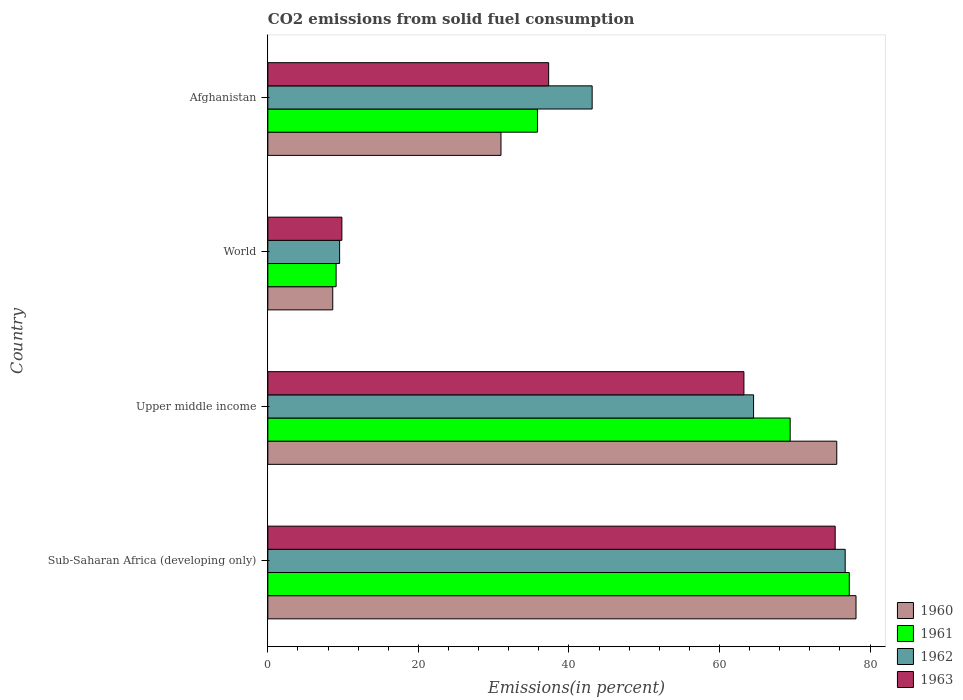How many different coloured bars are there?
Provide a short and direct response. 4. How many groups of bars are there?
Make the answer very short. 4. Are the number of bars on each tick of the Y-axis equal?
Make the answer very short. Yes. What is the label of the 3rd group of bars from the top?
Provide a succinct answer. Upper middle income. In how many cases, is the number of bars for a given country not equal to the number of legend labels?
Your answer should be compact. 0. What is the total CO2 emitted in 1963 in Upper middle income?
Make the answer very short. 63.25. Across all countries, what is the maximum total CO2 emitted in 1963?
Ensure brevity in your answer.  75.37. Across all countries, what is the minimum total CO2 emitted in 1962?
Offer a very short reply. 9.53. In which country was the total CO2 emitted in 1963 maximum?
Make the answer very short. Sub-Saharan Africa (developing only). In which country was the total CO2 emitted in 1960 minimum?
Give a very brief answer. World. What is the total total CO2 emitted in 1960 in the graph?
Offer a terse response. 193.32. What is the difference between the total CO2 emitted in 1962 in Upper middle income and that in World?
Your answer should be very brief. 55. What is the difference between the total CO2 emitted in 1960 in Sub-Saharan Africa (developing only) and the total CO2 emitted in 1963 in Afghanistan?
Offer a very short reply. 40.83. What is the average total CO2 emitted in 1961 per country?
Offer a very short reply. 47.88. What is the difference between the total CO2 emitted in 1961 and total CO2 emitted in 1962 in Afghanistan?
Make the answer very short. -7.26. In how many countries, is the total CO2 emitted in 1960 greater than 52 %?
Offer a terse response. 2. What is the ratio of the total CO2 emitted in 1960 in Sub-Saharan Africa (developing only) to that in Upper middle income?
Keep it short and to the point. 1.03. What is the difference between the highest and the second highest total CO2 emitted in 1963?
Keep it short and to the point. 12.13. What is the difference between the highest and the lowest total CO2 emitted in 1961?
Provide a short and direct response. 68.17. In how many countries, is the total CO2 emitted in 1961 greater than the average total CO2 emitted in 1961 taken over all countries?
Keep it short and to the point. 2. Is the sum of the total CO2 emitted in 1961 in Sub-Saharan Africa (developing only) and Upper middle income greater than the maximum total CO2 emitted in 1960 across all countries?
Offer a terse response. Yes. What does the 1st bar from the top in Upper middle income represents?
Provide a succinct answer. 1963. What does the 4th bar from the bottom in Sub-Saharan Africa (developing only) represents?
Ensure brevity in your answer.  1963. Is it the case that in every country, the sum of the total CO2 emitted in 1960 and total CO2 emitted in 1963 is greater than the total CO2 emitted in 1961?
Your response must be concise. Yes. How many countries are there in the graph?
Your answer should be compact. 4. Does the graph contain grids?
Provide a short and direct response. No. How many legend labels are there?
Give a very brief answer. 4. How are the legend labels stacked?
Offer a very short reply. Vertical. What is the title of the graph?
Make the answer very short. CO2 emissions from solid fuel consumption. What is the label or title of the X-axis?
Offer a very short reply. Emissions(in percent). What is the label or title of the Y-axis?
Ensure brevity in your answer.  Country. What is the Emissions(in percent) of 1960 in Sub-Saharan Africa (developing only)?
Provide a short and direct response. 78.14. What is the Emissions(in percent) in 1961 in Sub-Saharan Africa (developing only)?
Give a very brief answer. 77.24. What is the Emissions(in percent) in 1962 in Sub-Saharan Africa (developing only)?
Your answer should be compact. 76.7. What is the Emissions(in percent) of 1963 in Sub-Saharan Africa (developing only)?
Give a very brief answer. 75.37. What is the Emissions(in percent) in 1960 in Upper middle income?
Ensure brevity in your answer.  75.58. What is the Emissions(in percent) of 1961 in Upper middle income?
Your answer should be very brief. 69.39. What is the Emissions(in percent) of 1962 in Upper middle income?
Provide a short and direct response. 64.53. What is the Emissions(in percent) in 1963 in Upper middle income?
Your answer should be very brief. 63.25. What is the Emissions(in percent) in 1960 in World?
Provide a short and direct response. 8.62. What is the Emissions(in percent) in 1961 in World?
Offer a terse response. 9.07. What is the Emissions(in percent) in 1962 in World?
Keep it short and to the point. 9.53. What is the Emissions(in percent) of 1963 in World?
Your answer should be very brief. 9.83. What is the Emissions(in percent) in 1960 in Afghanistan?
Offer a terse response. 30.97. What is the Emissions(in percent) in 1961 in Afghanistan?
Provide a short and direct response. 35.82. What is the Emissions(in percent) in 1962 in Afghanistan?
Provide a short and direct response. 43.09. What is the Emissions(in percent) in 1963 in Afghanistan?
Offer a very short reply. 37.31. Across all countries, what is the maximum Emissions(in percent) in 1960?
Provide a short and direct response. 78.14. Across all countries, what is the maximum Emissions(in percent) in 1961?
Make the answer very short. 77.24. Across all countries, what is the maximum Emissions(in percent) in 1962?
Offer a very short reply. 76.7. Across all countries, what is the maximum Emissions(in percent) of 1963?
Offer a terse response. 75.37. Across all countries, what is the minimum Emissions(in percent) in 1960?
Make the answer very short. 8.62. Across all countries, what is the minimum Emissions(in percent) in 1961?
Offer a very short reply. 9.07. Across all countries, what is the minimum Emissions(in percent) of 1962?
Provide a succinct answer. 9.53. Across all countries, what is the minimum Emissions(in percent) of 1963?
Your response must be concise. 9.83. What is the total Emissions(in percent) of 1960 in the graph?
Offer a very short reply. 193.32. What is the total Emissions(in percent) in 1961 in the graph?
Offer a terse response. 191.53. What is the total Emissions(in percent) of 1962 in the graph?
Offer a very short reply. 193.85. What is the total Emissions(in percent) in 1963 in the graph?
Offer a terse response. 185.76. What is the difference between the Emissions(in percent) in 1960 in Sub-Saharan Africa (developing only) and that in Upper middle income?
Give a very brief answer. 2.56. What is the difference between the Emissions(in percent) in 1961 in Sub-Saharan Africa (developing only) and that in Upper middle income?
Your response must be concise. 7.85. What is the difference between the Emissions(in percent) of 1962 in Sub-Saharan Africa (developing only) and that in Upper middle income?
Keep it short and to the point. 12.17. What is the difference between the Emissions(in percent) in 1963 in Sub-Saharan Africa (developing only) and that in Upper middle income?
Your response must be concise. 12.13. What is the difference between the Emissions(in percent) of 1960 in Sub-Saharan Africa (developing only) and that in World?
Your answer should be compact. 69.52. What is the difference between the Emissions(in percent) of 1961 in Sub-Saharan Africa (developing only) and that in World?
Your answer should be very brief. 68.17. What is the difference between the Emissions(in percent) in 1962 in Sub-Saharan Africa (developing only) and that in World?
Offer a very short reply. 67.17. What is the difference between the Emissions(in percent) in 1963 in Sub-Saharan Africa (developing only) and that in World?
Offer a very short reply. 65.54. What is the difference between the Emissions(in percent) in 1960 in Sub-Saharan Africa (developing only) and that in Afghanistan?
Provide a succinct answer. 47.17. What is the difference between the Emissions(in percent) of 1961 in Sub-Saharan Africa (developing only) and that in Afghanistan?
Ensure brevity in your answer.  41.42. What is the difference between the Emissions(in percent) in 1962 in Sub-Saharan Africa (developing only) and that in Afghanistan?
Ensure brevity in your answer.  33.62. What is the difference between the Emissions(in percent) of 1963 in Sub-Saharan Africa (developing only) and that in Afghanistan?
Your answer should be compact. 38.07. What is the difference between the Emissions(in percent) of 1960 in Upper middle income and that in World?
Offer a terse response. 66.96. What is the difference between the Emissions(in percent) in 1961 in Upper middle income and that in World?
Ensure brevity in your answer.  60.32. What is the difference between the Emissions(in percent) in 1962 in Upper middle income and that in World?
Your response must be concise. 55. What is the difference between the Emissions(in percent) in 1963 in Upper middle income and that in World?
Offer a terse response. 53.41. What is the difference between the Emissions(in percent) of 1960 in Upper middle income and that in Afghanistan?
Make the answer very short. 44.61. What is the difference between the Emissions(in percent) of 1961 in Upper middle income and that in Afghanistan?
Provide a short and direct response. 33.57. What is the difference between the Emissions(in percent) of 1962 in Upper middle income and that in Afghanistan?
Your response must be concise. 21.45. What is the difference between the Emissions(in percent) in 1963 in Upper middle income and that in Afghanistan?
Your answer should be compact. 25.94. What is the difference between the Emissions(in percent) in 1960 in World and that in Afghanistan?
Your response must be concise. -22.35. What is the difference between the Emissions(in percent) of 1961 in World and that in Afghanistan?
Provide a short and direct response. -26.75. What is the difference between the Emissions(in percent) of 1962 in World and that in Afghanistan?
Your answer should be compact. -33.55. What is the difference between the Emissions(in percent) of 1963 in World and that in Afghanistan?
Give a very brief answer. -27.47. What is the difference between the Emissions(in percent) in 1960 in Sub-Saharan Africa (developing only) and the Emissions(in percent) in 1961 in Upper middle income?
Your response must be concise. 8.75. What is the difference between the Emissions(in percent) of 1960 in Sub-Saharan Africa (developing only) and the Emissions(in percent) of 1962 in Upper middle income?
Provide a short and direct response. 13.61. What is the difference between the Emissions(in percent) of 1960 in Sub-Saharan Africa (developing only) and the Emissions(in percent) of 1963 in Upper middle income?
Offer a terse response. 14.89. What is the difference between the Emissions(in percent) in 1961 in Sub-Saharan Africa (developing only) and the Emissions(in percent) in 1962 in Upper middle income?
Ensure brevity in your answer.  12.71. What is the difference between the Emissions(in percent) in 1961 in Sub-Saharan Africa (developing only) and the Emissions(in percent) in 1963 in Upper middle income?
Your answer should be very brief. 14. What is the difference between the Emissions(in percent) of 1962 in Sub-Saharan Africa (developing only) and the Emissions(in percent) of 1963 in Upper middle income?
Give a very brief answer. 13.45. What is the difference between the Emissions(in percent) of 1960 in Sub-Saharan Africa (developing only) and the Emissions(in percent) of 1961 in World?
Ensure brevity in your answer.  69.07. What is the difference between the Emissions(in percent) of 1960 in Sub-Saharan Africa (developing only) and the Emissions(in percent) of 1962 in World?
Your response must be concise. 68.61. What is the difference between the Emissions(in percent) in 1960 in Sub-Saharan Africa (developing only) and the Emissions(in percent) in 1963 in World?
Make the answer very short. 68.31. What is the difference between the Emissions(in percent) in 1961 in Sub-Saharan Africa (developing only) and the Emissions(in percent) in 1962 in World?
Your answer should be very brief. 67.71. What is the difference between the Emissions(in percent) in 1961 in Sub-Saharan Africa (developing only) and the Emissions(in percent) in 1963 in World?
Provide a short and direct response. 67.41. What is the difference between the Emissions(in percent) in 1962 in Sub-Saharan Africa (developing only) and the Emissions(in percent) in 1963 in World?
Provide a short and direct response. 66.87. What is the difference between the Emissions(in percent) of 1960 in Sub-Saharan Africa (developing only) and the Emissions(in percent) of 1961 in Afghanistan?
Your answer should be very brief. 42.32. What is the difference between the Emissions(in percent) of 1960 in Sub-Saharan Africa (developing only) and the Emissions(in percent) of 1962 in Afghanistan?
Keep it short and to the point. 35.06. What is the difference between the Emissions(in percent) in 1960 in Sub-Saharan Africa (developing only) and the Emissions(in percent) in 1963 in Afghanistan?
Your answer should be very brief. 40.83. What is the difference between the Emissions(in percent) of 1961 in Sub-Saharan Africa (developing only) and the Emissions(in percent) of 1962 in Afghanistan?
Give a very brief answer. 34.16. What is the difference between the Emissions(in percent) of 1961 in Sub-Saharan Africa (developing only) and the Emissions(in percent) of 1963 in Afghanistan?
Ensure brevity in your answer.  39.94. What is the difference between the Emissions(in percent) of 1962 in Sub-Saharan Africa (developing only) and the Emissions(in percent) of 1963 in Afghanistan?
Ensure brevity in your answer.  39.4. What is the difference between the Emissions(in percent) in 1960 in Upper middle income and the Emissions(in percent) in 1961 in World?
Your answer should be very brief. 66.51. What is the difference between the Emissions(in percent) of 1960 in Upper middle income and the Emissions(in percent) of 1962 in World?
Provide a short and direct response. 66.05. What is the difference between the Emissions(in percent) in 1960 in Upper middle income and the Emissions(in percent) in 1963 in World?
Ensure brevity in your answer.  65.75. What is the difference between the Emissions(in percent) in 1961 in Upper middle income and the Emissions(in percent) in 1962 in World?
Your answer should be compact. 59.86. What is the difference between the Emissions(in percent) of 1961 in Upper middle income and the Emissions(in percent) of 1963 in World?
Your response must be concise. 59.56. What is the difference between the Emissions(in percent) in 1962 in Upper middle income and the Emissions(in percent) in 1963 in World?
Give a very brief answer. 54.7. What is the difference between the Emissions(in percent) of 1960 in Upper middle income and the Emissions(in percent) of 1961 in Afghanistan?
Make the answer very short. 39.76. What is the difference between the Emissions(in percent) in 1960 in Upper middle income and the Emissions(in percent) in 1962 in Afghanistan?
Your answer should be very brief. 32.5. What is the difference between the Emissions(in percent) in 1960 in Upper middle income and the Emissions(in percent) in 1963 in Afghanistan?
Keep it short and to the point. 38.28. What is the difference between the Emissions(in percent) of 1961 in Upper middle income and the Emissions(in percent) of 1962 in Afghanistan?
Give a very brief answer. 26.31. What is the difference between the Emissions(in percent) in 1961 in Upper middle income and the Emissions(in percent) in 1963 in Afghanistan?
Provide a succinct answer. 32.09. What is the difference between the Emissions(in percent) of 1962 in Upper middle income and the Emissions(in percent) of 1963 in Afghanistan?
Make the answer very short. 27.22. What is the difference between the Emissions(in percent) in 1960 in World and the Emissions(in percent) in 1961 in Afghanistan?
Your answer should be compact. -27.2. What is the difference between the Emissions(in percent) in 1960 in World and the Emissions(in percent) in 1962 in Afghanistan?
Your answer should be very brief. -34.46. What is the difference between the Emissions(in percent) of 1960 in World and the Emissions(in percent) of 1963 in Afghanistan?
Provide a short and direct response. -28.68. What is the difference between the Emissions(in percent) of 1961 in World and the Emissions(in percent) of 1962 in Afghanistan?
Ensure brevity in your answer.  -34.02. What is the difference between the Emissions(in percent) of 1961 in World and the Emissions(in percent) of 1963 in Afghanistan?
Provide a succinct answer. -28.24. What is the difference between the Emissions(in percent) of 1962 in World and the Emissions(in percent) of 1963 in Afghanistan?
Your answer should be very brief. -27.77. What is the average Emissions(in percent) of 1960 per country?
Ensure brevity in your answer.  48.33. What is the average Emissions(in percent) in 1961 per country?
Make the answer very short. 47.88. What is the average Emissions(in percent) of 1962 per country?
Your response must be concise. 48.46. What is the average Emissions(in percent) in 1963 per country?
Your response must be concise. 46.44. What is the difference between the Emissions(in percent) of 1960 and Emissions(in percent) of 1961 in Sub-Saharan Africa (developing only)?
Give a very brief answer. 0.9. What is the difference between the Emissions(in percent) of 1960 and Emissions(in percent) of 1962 in Sub-Saharan Africa (developing only)?
Your answer should be compact. 1.44. What is the difference between the Emissions(in percent) of 1960 and Emissions(in percent) of 1963 in Sub-Saharan Africa (developing only)?
Give a very brief answer. 2.77. What is the difference between the Emissions(in percent) in 1961 and Emissions(in percent) in 1962 in Sub-Saharan Africa (developing only)?
Ensure brevity in your answer.  0.54. What is the difference between the Emissions(in percent) in 1961 and Emissions(in percent) in 1963 in Sub-Saharan Africa (developing only)?
Give a very brief answer. 1.87. What is the difference between the Emissions(in percent) of 1962 and Emissions(in percent) of 1963 in Sub-Saharan Africa (developing only)?
Ensure brevity in your answer.  1.33. What is the difference between the Emissions(in percent) of 1960 and Emissions(in percent) of 1961 in Upper middle income?
Your answer should be compact. 6.19. What is the difference between the Emissions(in percent) in 1960 and Emissions(in percent) in 1962 in Upper middle income?
Make the answer very short. 11.05. What is the difference between the Emissions(in percent) of 1960 and Emissions(in percent) of 1963 in Upper middle income?
Offer a terse response. 12.33. What is the difference between the Emissions(in percent) in 1961 and Emissions(in percent) in 1962 in Upper middle income?
Your answer should be very brief. 4.86. What is the difference between the Emissions(in percent) of 1961 and Emissions(in percent) of 1963 in Upper middle income?
Ensure brevity in your answer.  6.14. What is the difference between the Emissions(in percent) in 1962 and Emissions(in percent) in 1963 in Upper middle income?
Offer a terse response. 1.28. What is the difference between the Emissions(in percent) in 1960 and Emissions(in percent) in 1961 in World?
Ensure brevity in your answer.  -0.45. What is the difference between the Emissions(in percent) in 1960 and Emissions(in percent) in 1962 in World?
Your answer should be very brief. -0.91. What is the difference between the Emissions(in percent) in 1960 and Emissions(in percent) in 1963 in World?
Provide a succinct answer. -1.21. What is the difference between the Emissions(in percent) in 1961 and Emissions(in percent) in 1962 in World?
Give a very brief answer. -0.46. What is the difference between the Emissions(in percent) in 1961 and Emissions(in percent) in 1963 in World?
Ensure brevity in your answer.  -0.77. What is the difference between the Emissions(in percent) in 1962 and Emissions(in percent) in 1963 in World?
Give a very brief answer. -0.3. What is the difference between the Emissions(in percent) of 1960 and Emissions(in percent) of 1961 in Afghanistan?
Offer a very short reply. -4.85. What is the difference between the Emissions(in percent) in 1960 and Emissions(in percent) in 1962 in Afghanistan?
Provide a succinct answer. -12.11. What is the difference between the Emissions(in percent) of 1960 and Emissions(in percent) of 1963 in Afghanistan?
Ensure brevity in your answer.  -6.33. What is the difference between the Emissions(in percent) in 1961 and Emissions(in percent) in 1962 in Afghanistan?
Provide a short and direct response. -7.26. What is the difference between the Emissions(in percent) of 1961 and Emissions(in percent) of 1963 in Afghanistan?
Make the answer very short. -1.48. What is the difference between the Emissions(in percent) in 1962 and Emissions(in percent) in 1963 in Afghanistan?
Make the answer very short. 5.78. What is the ratio of the Emissions(in percent) in 1960 in Sub-Saharan Africa (developing only) to that in Upper middle income?
Provide a succinct answer. 1.03. What is the ratio of the Emissions(in percent) in 1961 in Sub-Saharan Africa (developing only) to that in Upper middle income?
Your response must be concise. 1.11. What is the ratio of the Emissions(in percent) of 1962 in Sub-Saharan Africa (developing only) to that in Upper middle income?
Provide a succinct answer. 1.19. What is the ratio of the Emissions(in percent) in 1963 in Sub-Saharan Africa (developing only) to that in Upper middle income?
Your response must be concise. 1.19. What is the ratio of the Emissions(in percent) in 1960 in Sub-Saharan Africa (developing only) to that in World?
Ensure brevity in your answer.  9.06. What is the ratio of the Emissions(in percent) of 1961 in Sub-Saharan Africa (developing only) to that in World?
Provide a succinct answer. 8.52. What is the ratio of the Emissions(in percent) in 1962 in Sub-Saharan Africa (developing only) to that in World?
Offer a very short reply. 8.05. What is the ratio of the Emissions(in percent) of 1963 in Sub-Saharan Africa (developing only) to that in World?
Your answer should be compact. 7.66. What is the ratio of the Emissions(in percent) of 1960 in Sub-Saharan Africa (developing only) to that in Afghanistan?
Give a very brief answer. 2.52. What is the ratio of the Emissions(in percent) of 1961 in Sub-Saharan Africa (developing only) to that in Afghanistan?
Provide a short and direct response. 2.16. What is the ratio of the Emissions(in percent) of 1962 in Sub-Saharan Africa (developing only) to that in Afghanistan?
Make the answer very short. 1.78. What is the ratio of the Emissions(in percent) of 1963 in Sub-Saharan Africa (developing only) to that in Afghanistan?
Offer a terse response. 2.02. What is the ratio of the Emissions(in percent) in 1960 in Upper middle income to that in World?
Offer a terse response. 8.76. What is the ratio of the Emissions(in percent) in 1961 in Upper middle income to that in World?
Your answer should be compact. 7.65. What is the ratio of the Emissions(in percent) in 1962 in Upper middle income to that in World?
Your answer should be compact. 6.77. What is the ratio of the Emissions(in percent) of 1963 in Upper middle income to that in World?
Provide a succinct answer. 6.43. What is the ratio of the Emissions(in percent) in 1960 in Upper middle income to that in Afghanistan?
Keep it short and to the point. 2.44. What is the ratio of the Emissions(in percent) in 1961 in Upper middle income to that in Afghanistan?
Your response must be concise. 1.94. What is the ratio of the Emissions(in percent) of 1962 in Upper middle income to that in Afghanistan?
Make the answer very short. 1.5. What is the ratio of the Emissions(in percent) in 1963 in Upper middle income to that in Afghanistan?
Offer a very short reply. 1.7. What is the ratio of the Emissions(in percent) of 1960 in World to that in Afghanistan?
Keep it short and to the point. 0.28. What is the ratio of the Emissions(in percent) of 1961 in World to that in Afghanistan?
Offer a terse response. 0.25. What is the ratio of the Emissions(in percent) of 1962 in World to that in Afghanistan?
Your response must be concise. 0.22. What is the ratio of the Emissions(in percent) in 1963 in World to that in Afghanistan?
Ensure brevity in your answer.  0.26. What is the difference between the highest and the second highest Emissions(in percent) in 1960?
Make the answer very short. 2.56. What is the difference between the highest and the second highest Emissions(in percent) in 1961?
Ensure brevity in your answer.  7.85. What is the difference between the highest and the second highest Emissions(in percent) in 1962?
Offer a very short reply. 12.17. What is the difference between the highest and the second highest Emissions(in percent) in 1963?
Your answer should be very brief. 12.13. What is the difference between the highest and the lowest Emissions(in percent) of 1960?
Offer a very short reply. 69.52. What is the difference between the highest and the lowest Emissions(in percent) of 1961?
Provide a succinct answer. 68.17. What is the difference between the highest and the lowest Emissions(in percent) of 1962?
Provide a succinct answer. 67.17. What is the difference between the highest and the lowest Emissions(in percent) in 1963?
Your response must be concise. 65.54. 